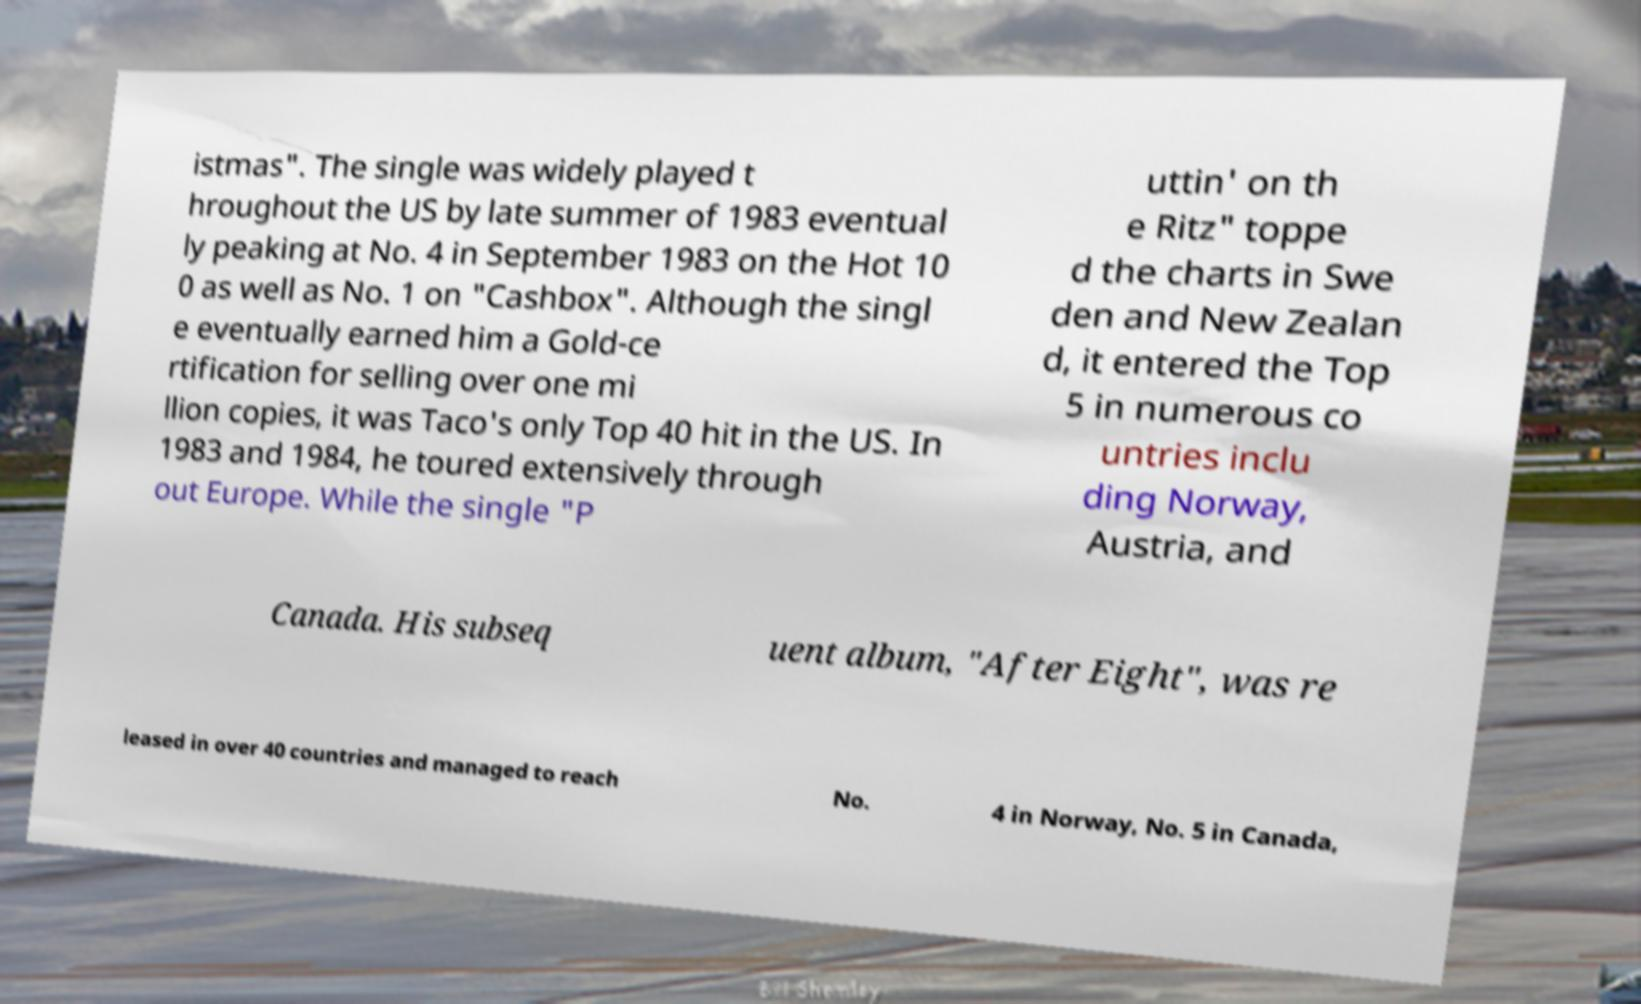Can you accurately transcribe the text from the provided image for me? istmas". The single was widely played t hroughout the US by late summer of 1983 eventual ly peaking at No. 4 in September 1983 on the Hot 10 0 as well as No. 1 on "Cashbox". Although the singl e eventually earned him a Gold-ce rtification for selling over one mi llion copies, it was Taco's only Top 40 hit in the US. In 1983 and 1984, he toured extensively through out Europe. While the single "P uttin' on th e Ritz" toppe d the charts in Swe den and New Zealan d, it entered the Top 5 in numerous co untries inclu ding Norway, Austria, and Canada. His subseq uent album, "After Eight", was re leased in over 40 countries and managed to reach No. 4 in Norway, No. 5 in Canada, 